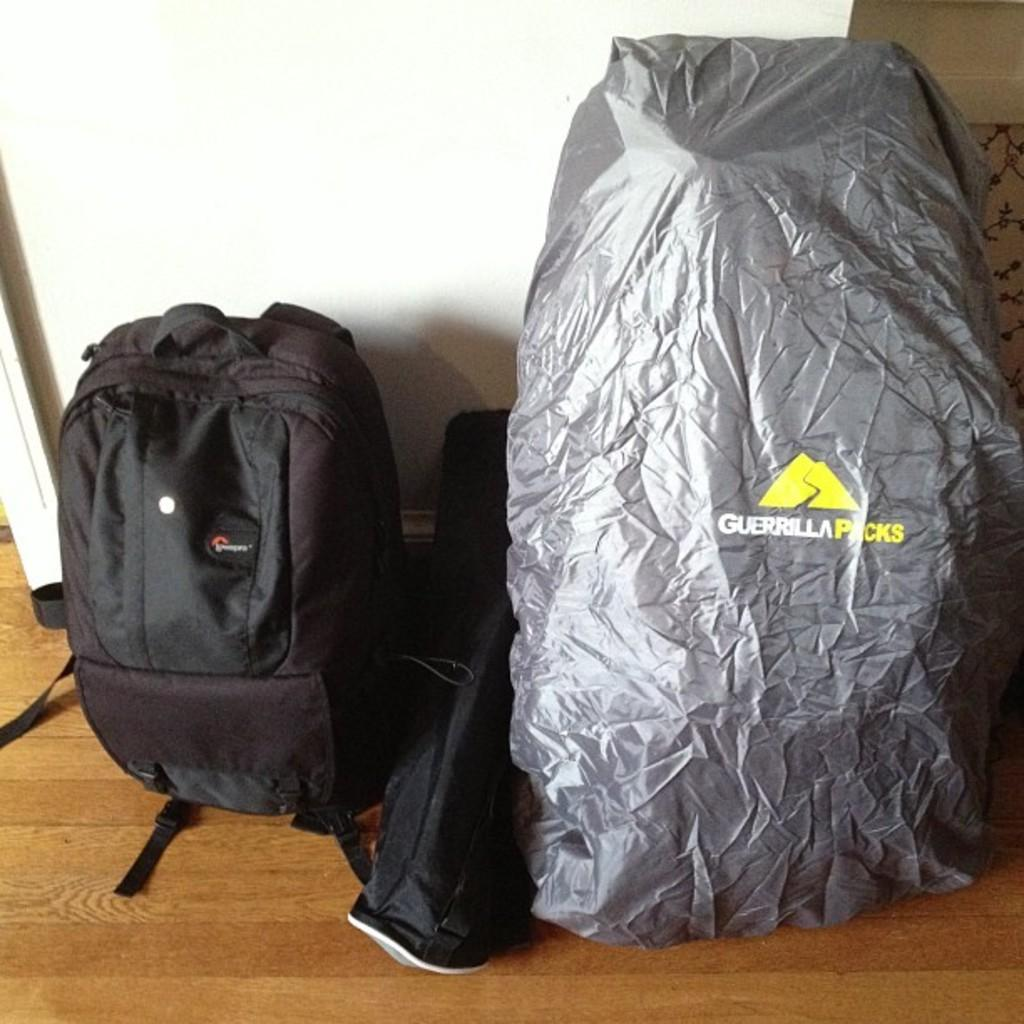<image>
Summarize the visual content of the image. a bag with the word Guerilla Picks on it 